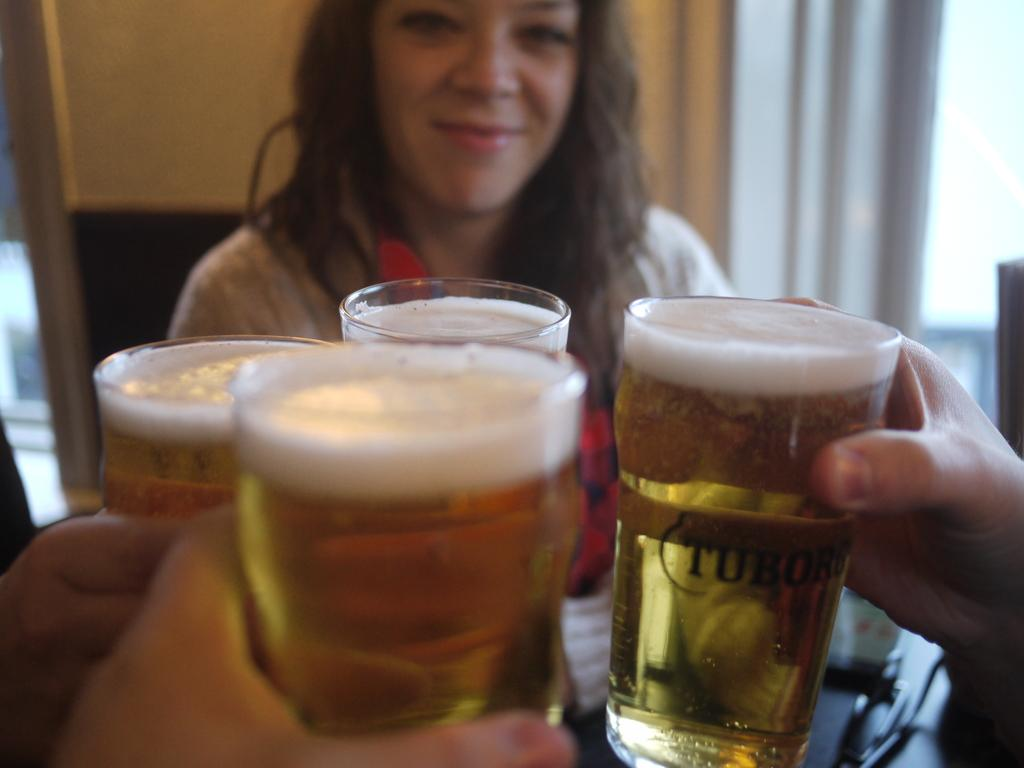What can be seen in the foreground of the image? There are hands holding glasses of drinks in the foreground of the image. Are there any other people in the image besides the hands? Yes, there is another person in the image. What else can be seen in the background of the image? There are other objects visible in the background of the image. What type of quince is being used as a whistle by the person in the image? There is no quince or whistle present in the image. What is the health status of the person in the image? The health status of the person in the image cannot be determined from the image alone. 